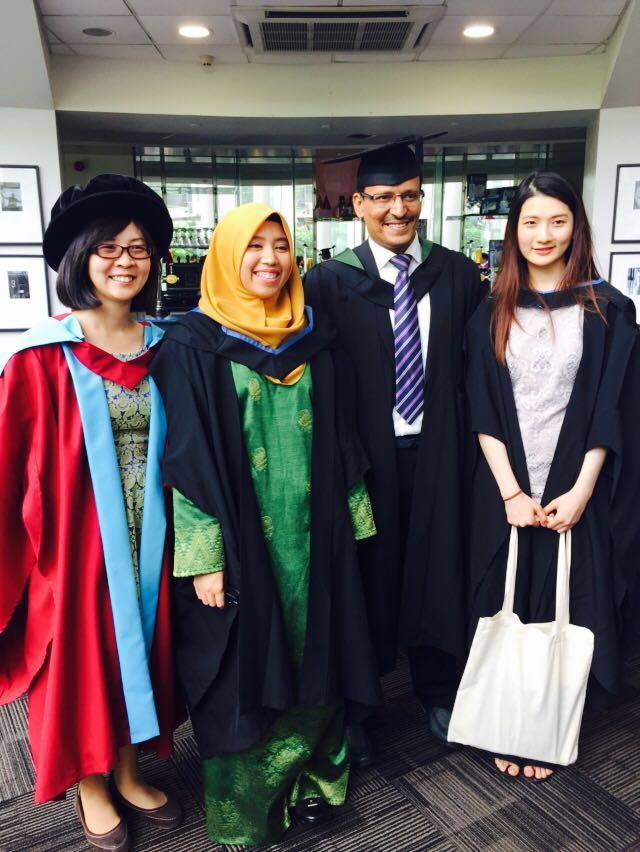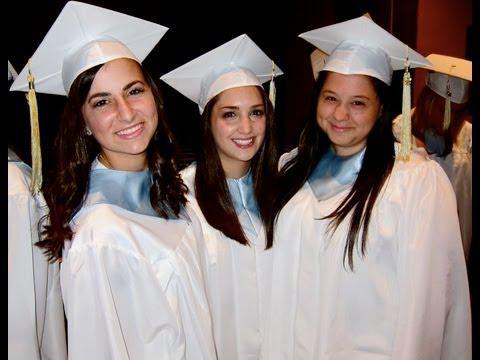The first image is the image on the left, the second image is the image on the right. Analyze the images presented: Is the assertion "One of the images has one man and at least 3 women." valid? Answer yes or no. Yes. 